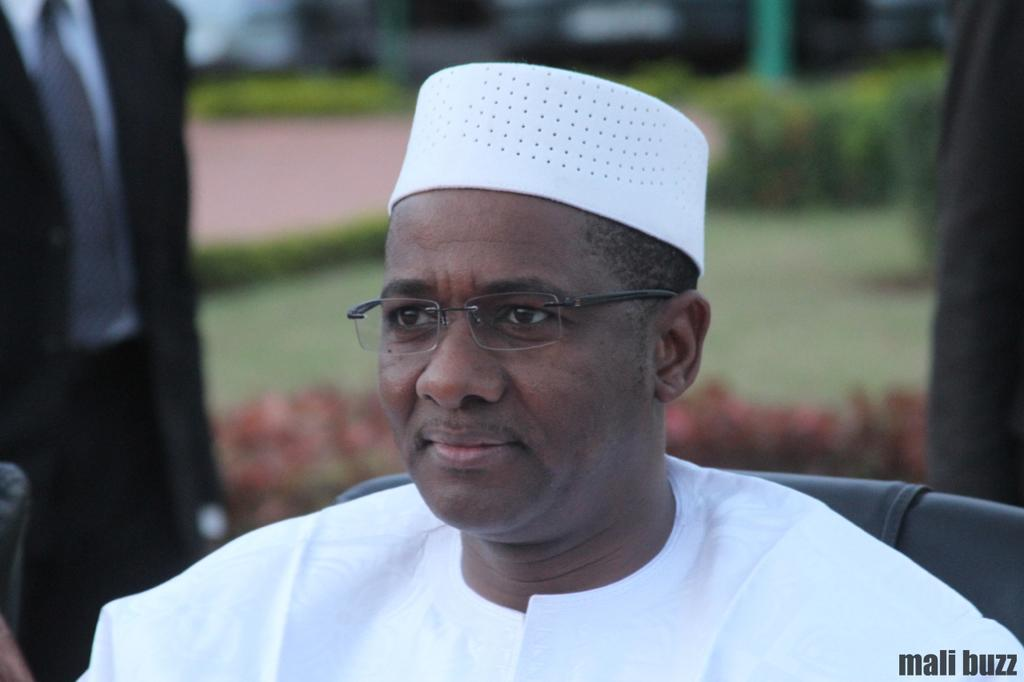What is the man in the image doing? The man is sitting in the image. What can be seen on the man's head? The man is wearing a white cap. What is the man wearing as his primary clothing? The man is wearing a white dress. Can you describe the background of the image? The background of the image is blurred. What question is the doll asking in the image? There is no doll present in the image, so it is not possible to answer that question. 